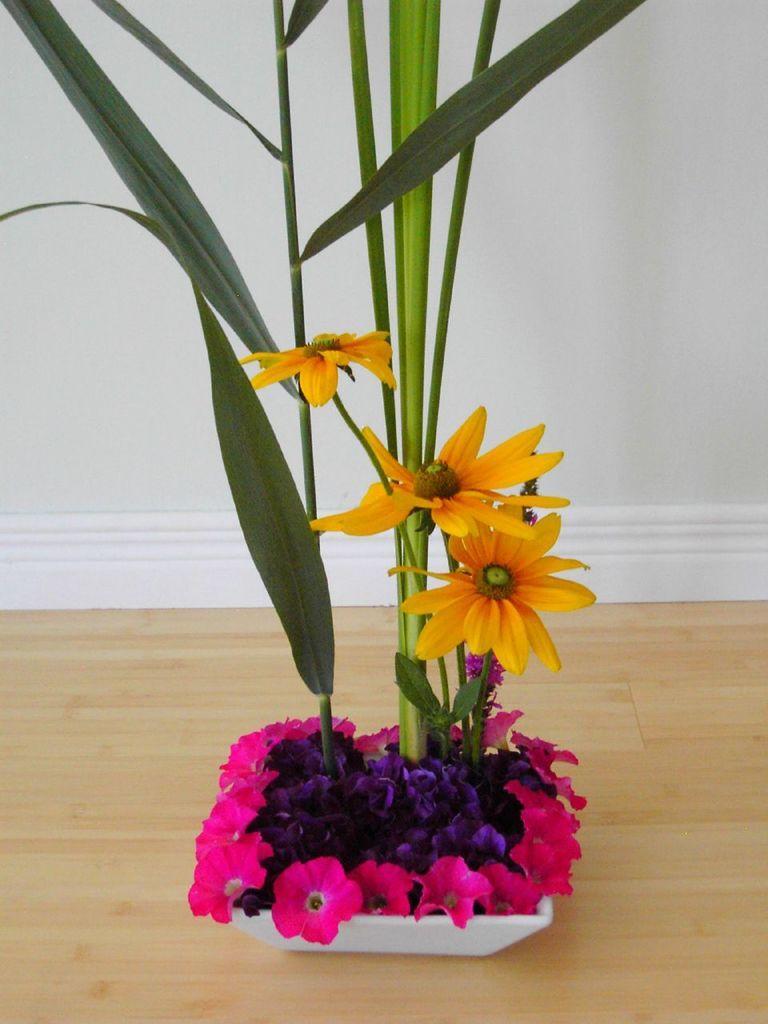Can you describe this image briefly? This image consists of a flower which is in the pot white in colour. 